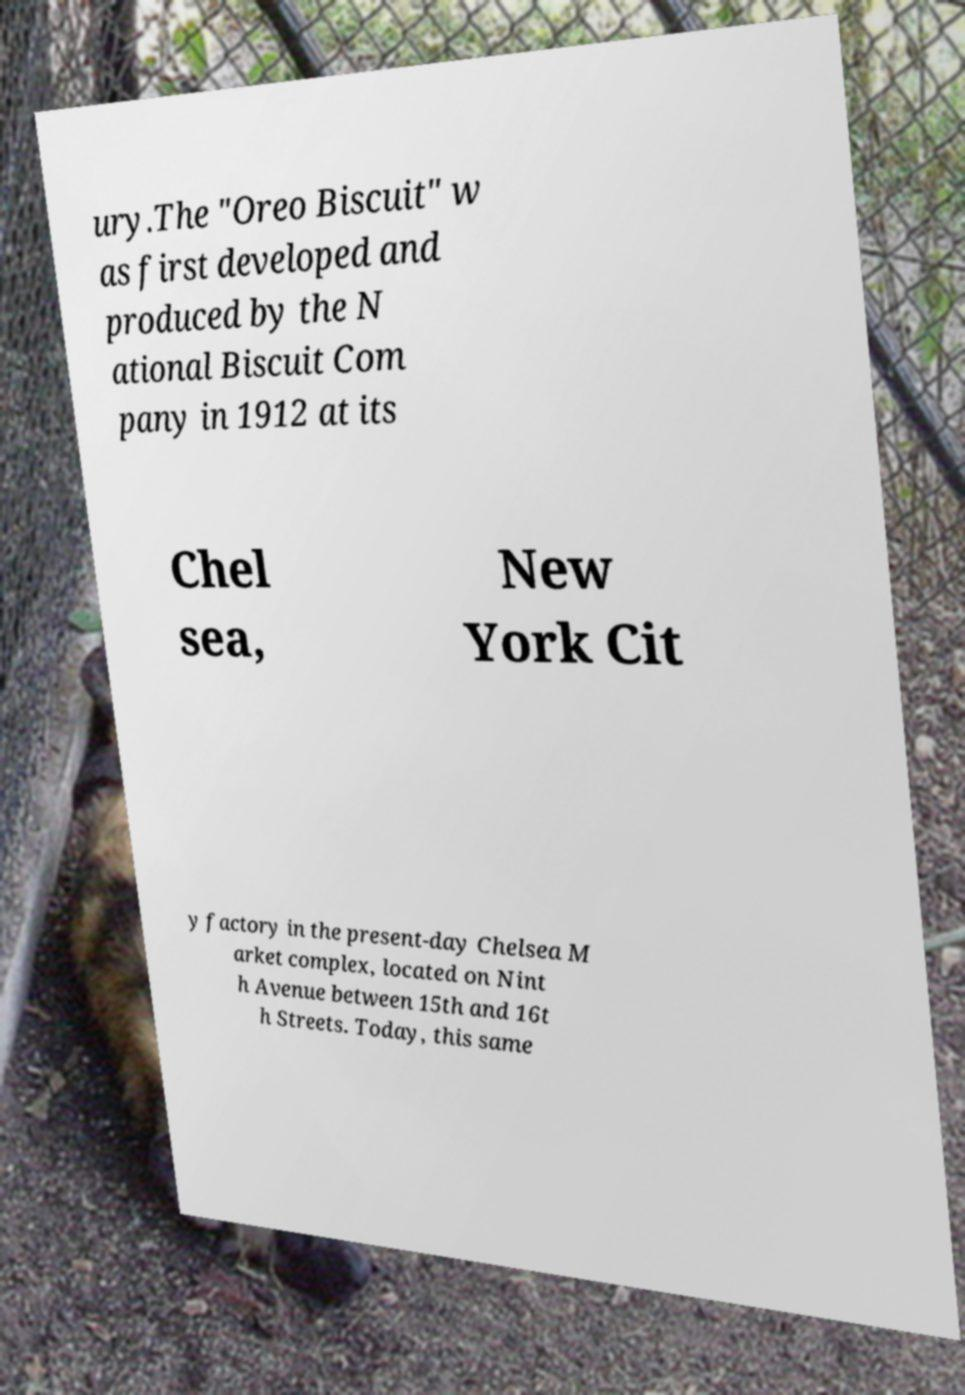For documentation purposes, I need the text within this image transcribed. Could you provide that? ury.The "Oreo Biscuit" w as first developed and produced by the N ational Biscuit Com pany in 1912 at its Chel sea, New York Cit y factory in the present-day Chelsea M arket complex, located on Nint h Avenue between 15th and 16t h Streets. Today, this same 